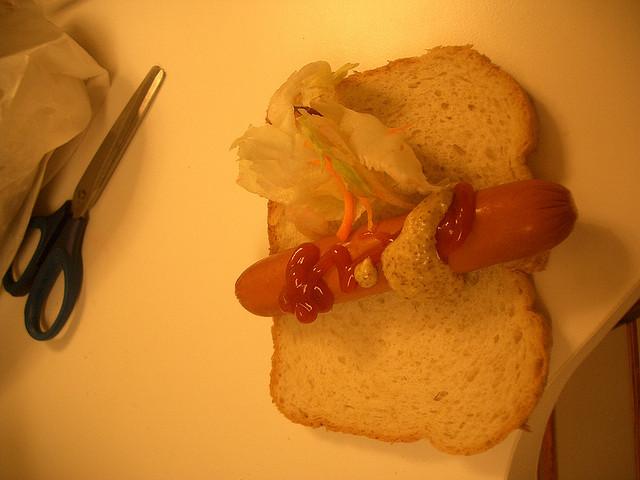What type of hotdog is shown?
Answer briefly. Beef. Is the meal expensive?
Answer briefly. No. Is there bird feces on the hot dog?
Write a very short answer. No. 